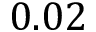Convert formula to latex. <formula><loc_0><loc_0><loc_500><loc_500>0 . 0 2</formula> 